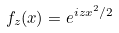<formula> <loc_0><loc_0><loc_500><loc_500>f _ { z } ( x ) = e ^ { i z x ^ { 2 } / 2 }</formula> 